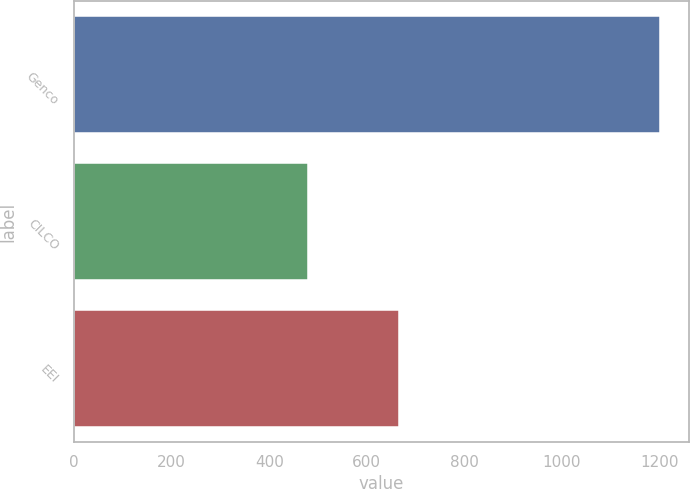Convert chart to OTSL. <chart><loc_0><loc_0><loc_500><loc_500><bar_chart><fcel>Genco<fcel>CILCO<fcel>EEI<nl><fcel>1200<fcel>480<fcel>665<nl></chart> 